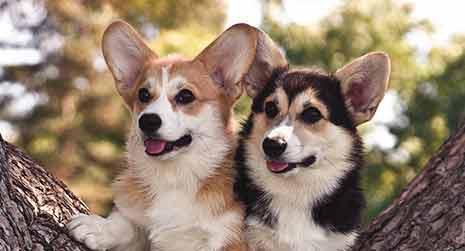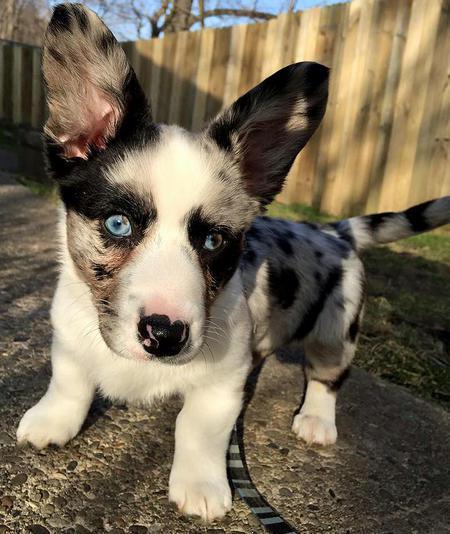The first image is the image on the left, the second image is the image on the right. For the images shown, is this caption "The images show a total of two short-legged dogs facing in opposite directions." true? Answer yes or no. No. 